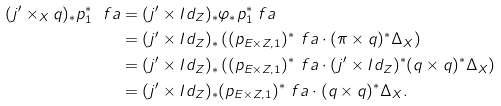Convert formula to latex. <formula><loc_0><loc_0><loc_500><loc_500>( j ^ { \prime } \times _ { X } q ) _ { * } p _ { 1 } ^ { * } \ f a & = ( j ^ { \prime } \times I d _ { Z } ) _ { * } \varphi _ { * } p _ { 1 } ^ { * } \ f a \\ & = ( j ^ { \prime } \times I d _ { Z } ) _ { * } \left ( ( p _ { E \times Z , 1 } ) ^ { * } \ f a \cdot ( \pi \times q ) ^ { * } \Delta _ { X } \right ) \\ & = ( j ^ { \prime } \times I d _ { Z } ) _ { * } \left ( ( p _ { E \times Z , 1 } ) ^ { * } \ f a \cdot ( j ^ { \prime } \times I d _ { Z } ) ^ { * } ( q \times q ) ^ { * } \Delta _ { X } \right ) \\ & = ( j ^ { \prime } \times I d _ { Z } ) _ { * } ( p _ { E \times Z , 1 } ) ^ { * } \ f a \cdot ( q \times q ) ^ { * } \Delta _ { X } .</formula> 